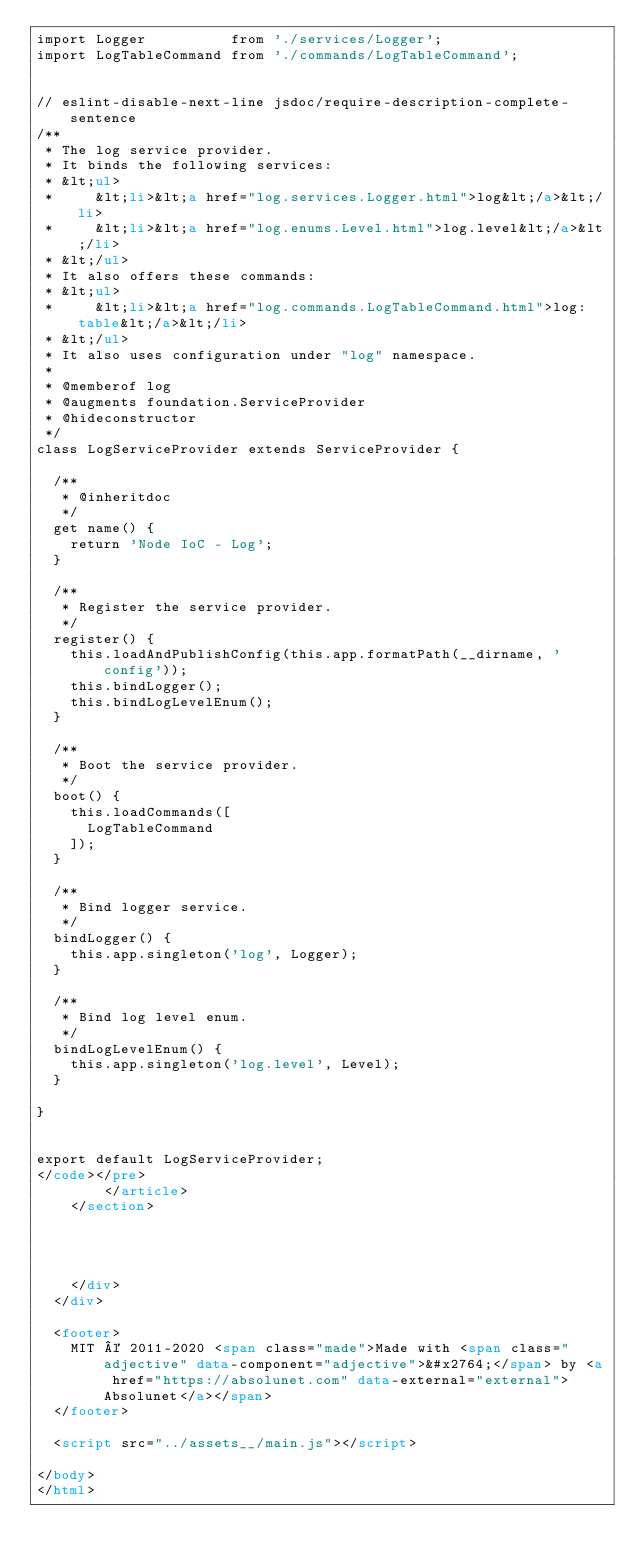Convert code to text. <code><loc_0><loc_0><loc_500><loc_500><_HTML_>import Logger          from './services/Logger';
import LogTableCommand from './commands/LogTableCommand';


// eslint-disable-next-line jsdoc/require-description-complete-sentence
/**
 * The log service provider.
 * It binds the following services:
 * &lt;ul>
 *     &lt;li>&lt;a href="log.services.Logger.html">log&lt;/a>&lt;/li>
 *     &lt;li>&lt;a href="log.enums.Level.html">log.level&lt;/a>&lt;/li>
 * &lt;/ul>
 * It also offers these commands:
 * &lt;ul>
 *     &lt;li>&lt;a href="log.commands.LogTableCommand.html">log:table&lt;/a>&lt;/li>
 * &lt;/ul>
 * It also uses configuration under "log" namespace.
 *
 * @memberof log
 * @augments foundation.ServiceProvider
 * @hideconstructor
 */
class LogServiceProvider extends ServiceProvider {

	/**
	 * @inheritdoc
	 */
	get name() {
		return 'Node IoC - Log';
	}

	/**
	 * Register the service provider.
	 */
	register() {
		this.loadAndPublishConfig(this.app.formatPath(__dirname, 'config'));
		this.bindLogger();
		this.bindLogLevelEnum();
	}

	/**
	 * Boot the service provider.
	 */
	boot() {
		this.loadCommands([
			LogTableCommand
		]);
	}

	/**
	 * Bind logger service.
	 */
	bindLogger() {
		this.app.singleton('log', Logger);
	}

	/**
	 * Bind log level enum.
	 */
	bindLogLevelEnum() {
		this.app.singleton('log.level', Level);
	}

}


export default LogServiceProvider;
</code></pre>
        </article>
    </section>




		</div>
	</div>

	<footer>
		MIT © 2011-2020 <span class="made">Made with <span class="adjective" data-component="adjective">&#x2764;</span> by <a href="https://absolunet.com" data-external="external">Absolunet</a></span>
	</footer>

	<script src="../assets__/main.js"></script>

</body>
</html>
</code> 